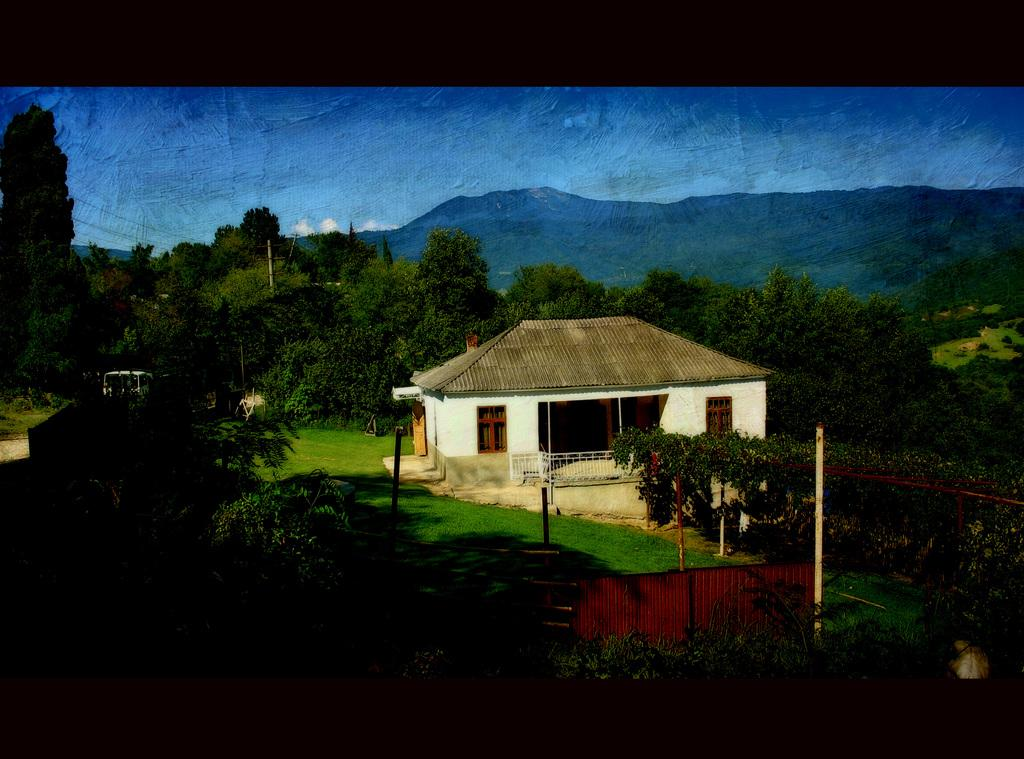What type of artwork is shown in the image? The image appears to be a painting. What is the main subject of the painting? The painting depicts a house. What other elements are included in the painting? The painting includes trees. What can be seen in the distance behind the house and trees? There are mountains visible in the background of the painting. How many cherries are hanging from the tree in the painting? There are no cherries visible in the painting; it only includes trees and mountains. Is there a yard surrounding the house in the painting? The provided facts do not mention a yard surrounding the house, so we cannot definitively answer that question. 